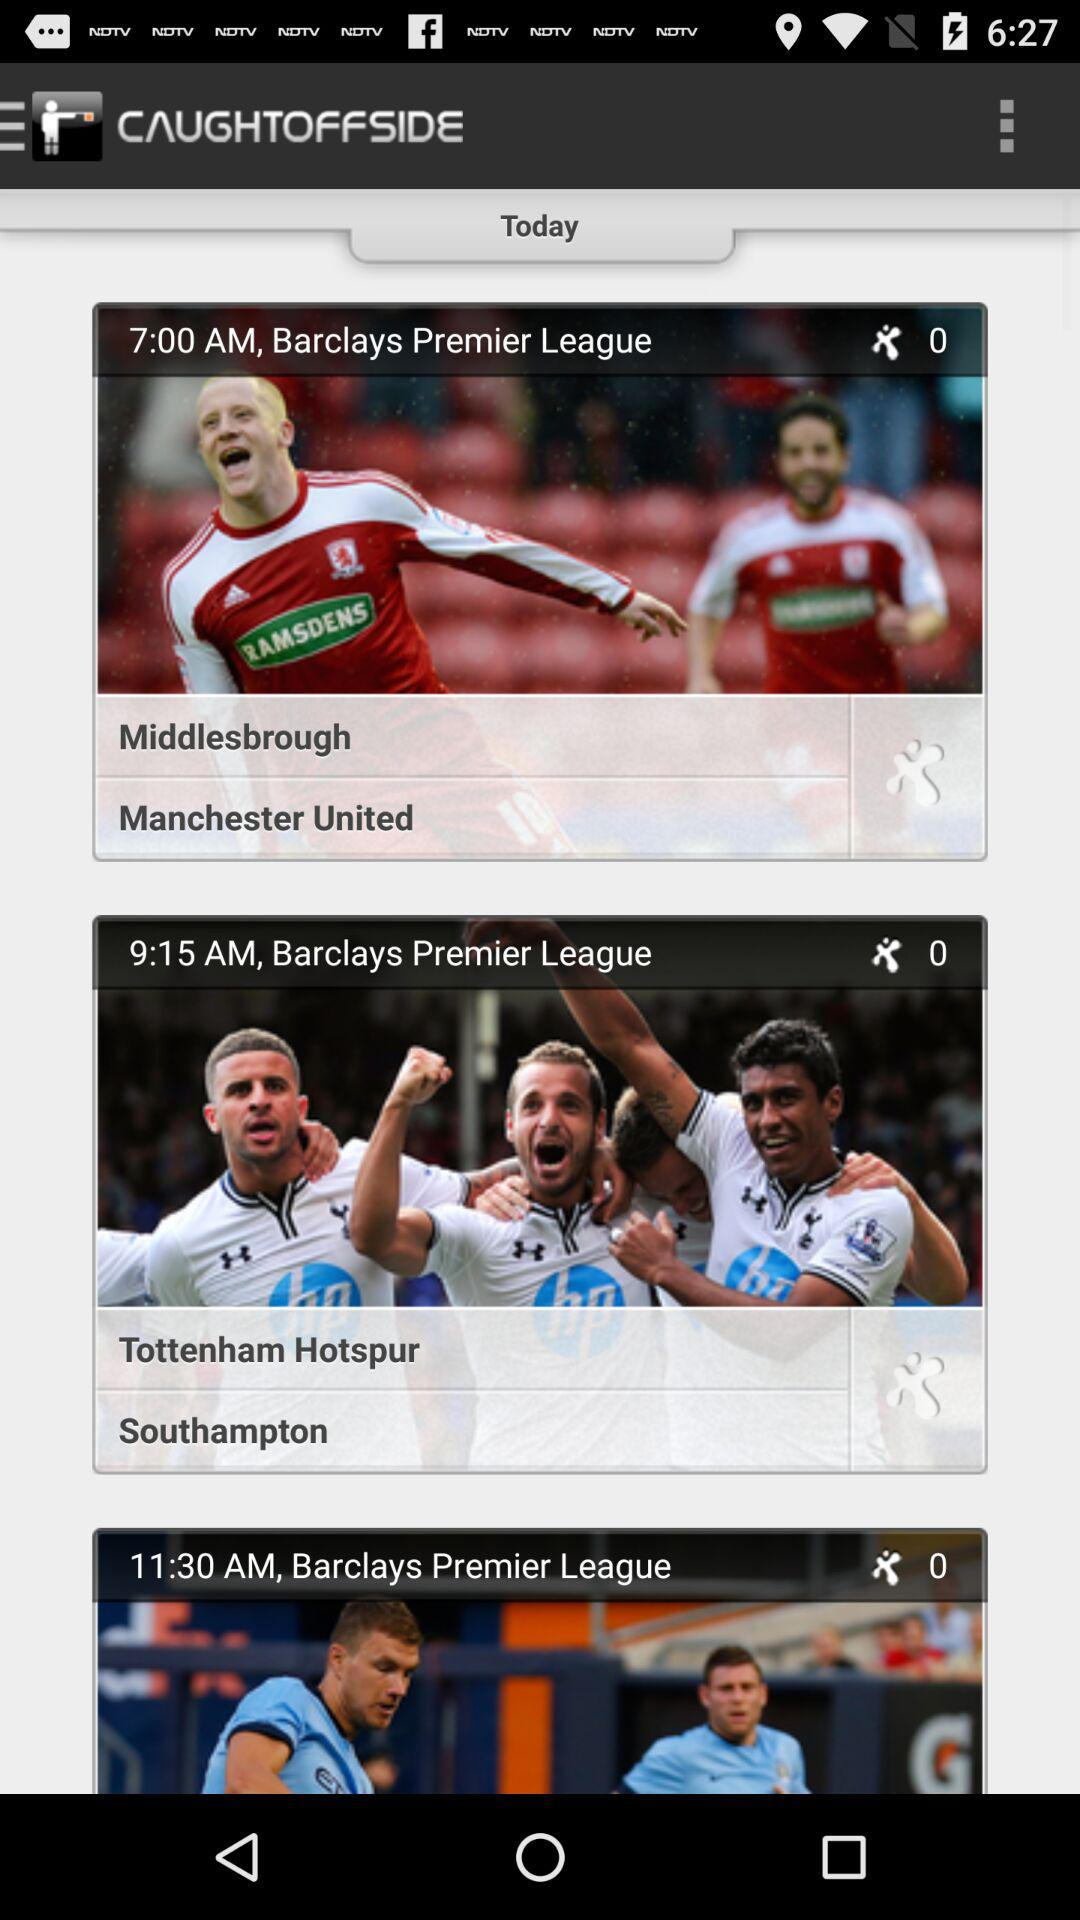How many matches are there in the Barclays Premier League?
Answer the question using a single word or phrase. 3 